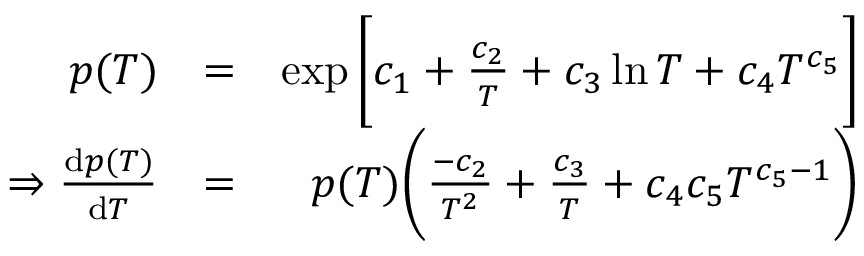Convert formula to latex. <formula><loc_0><loc_0><loc_500><loc_500>\begin{array} { r l r } { p ( T ) } & { = } & { \exp \left [ c _ { 1 } + \frac { c _ { 2 } } { T } + c _ { 3 } \ln T + c _ { 4 } T ^ { c _ { 5 } } \right ] } \\ { \Rightarrow \frac { d p ( T ) } { d T } } & { = } & { p ( T ) \left ( \frac { - c _ { 2 } } { T ^ { 2 } } + \frac { c _ { 3 } } { T } + c _ { 4 } c _ { 5 } T ^ { c _ { 5 } - 1 } \right ) } \end{array}</formula> 